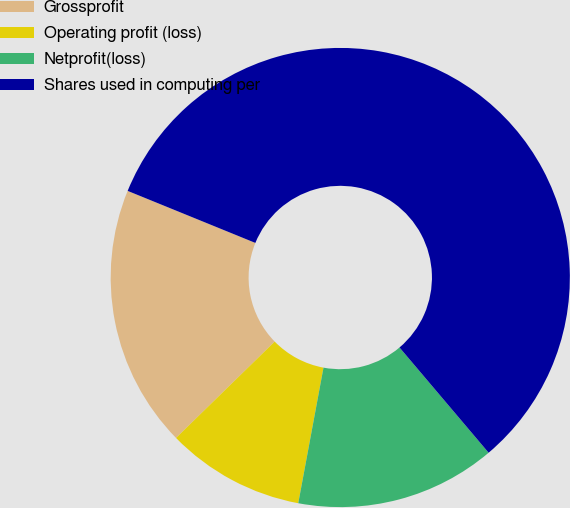Convert chart to OTSL. <chart><loc_0><loc_0><loc_500><loc_500><pie_chart><fcel>Grossprofit<fcel>Operating profit (loss)<fcel>Netprofit(loss)<fcel>Shares used in computing per<nl><fcel>18.47%<fcel>9.76%<fcel>14.11%<fcel>57.66%<nl></chart> 